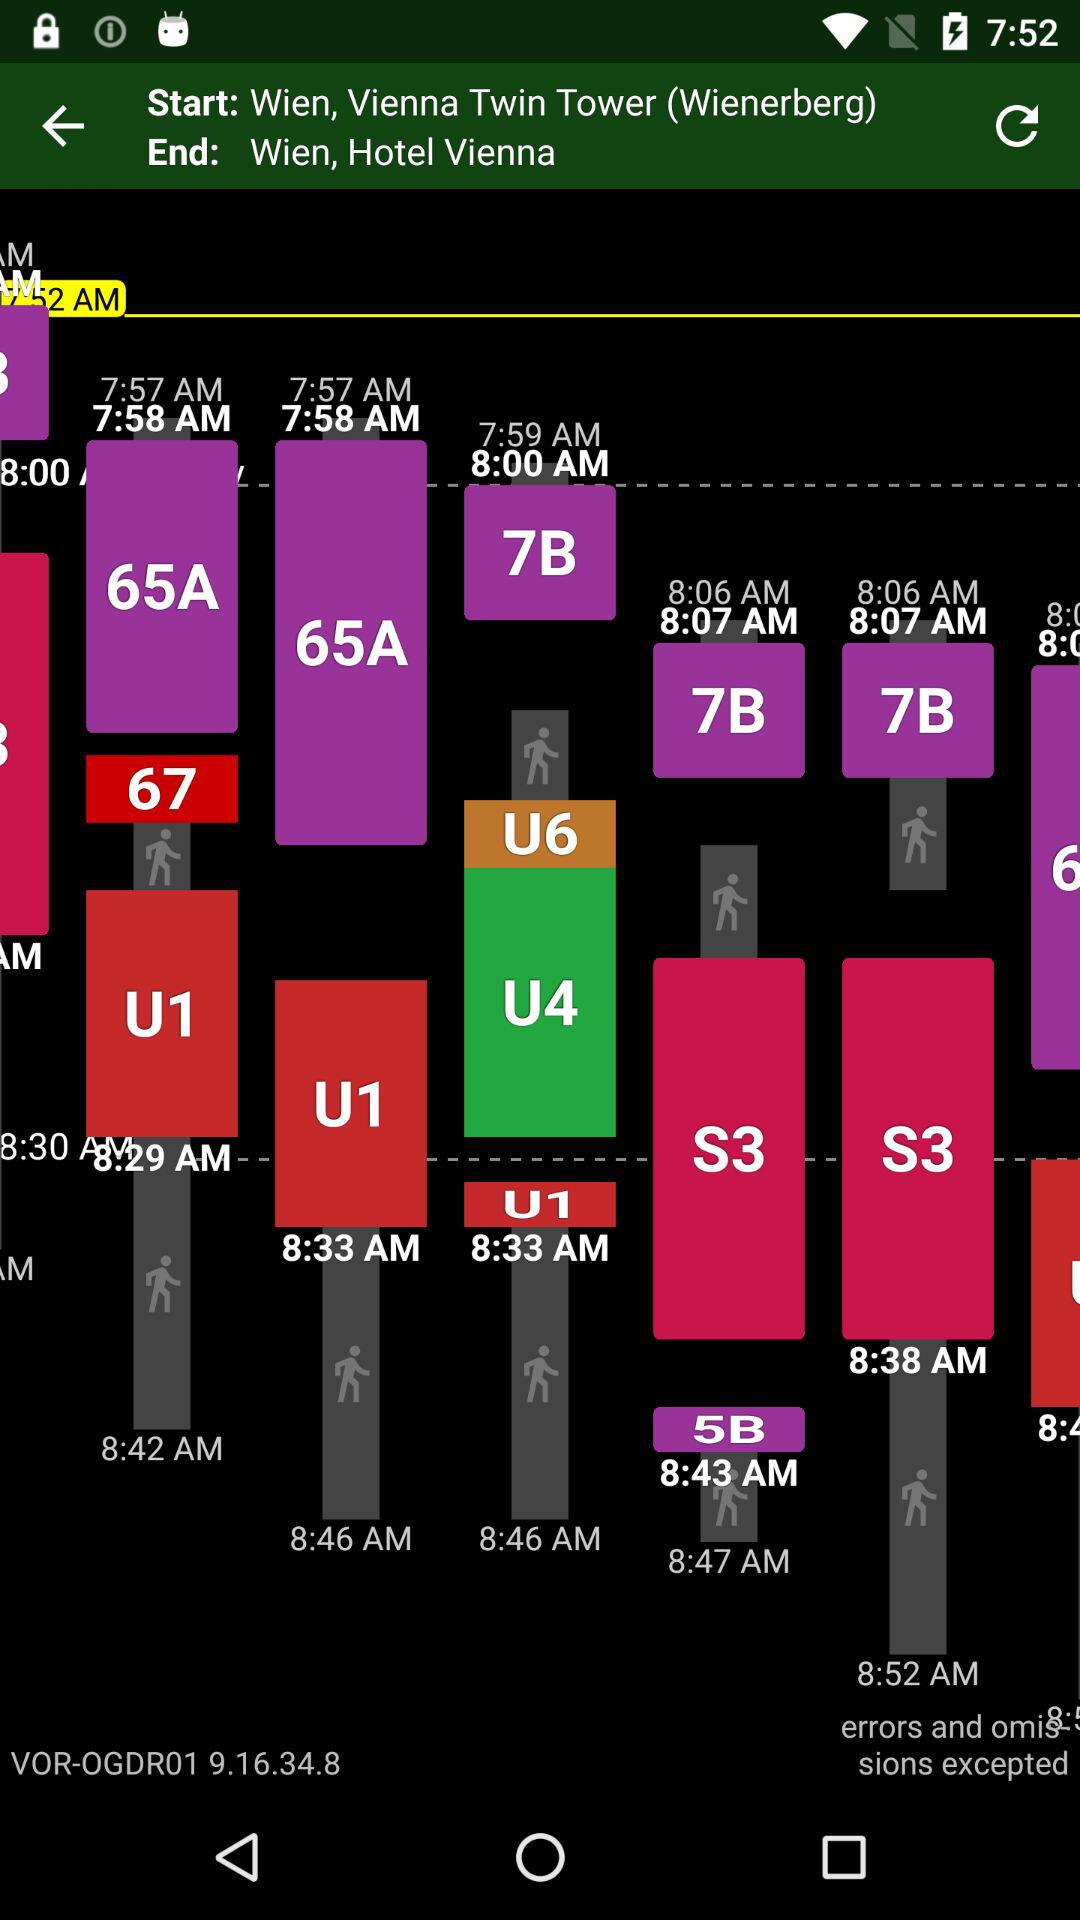What is the starting location? The starting location is Wien, Vienna Twin Tower (Wienerberg). 